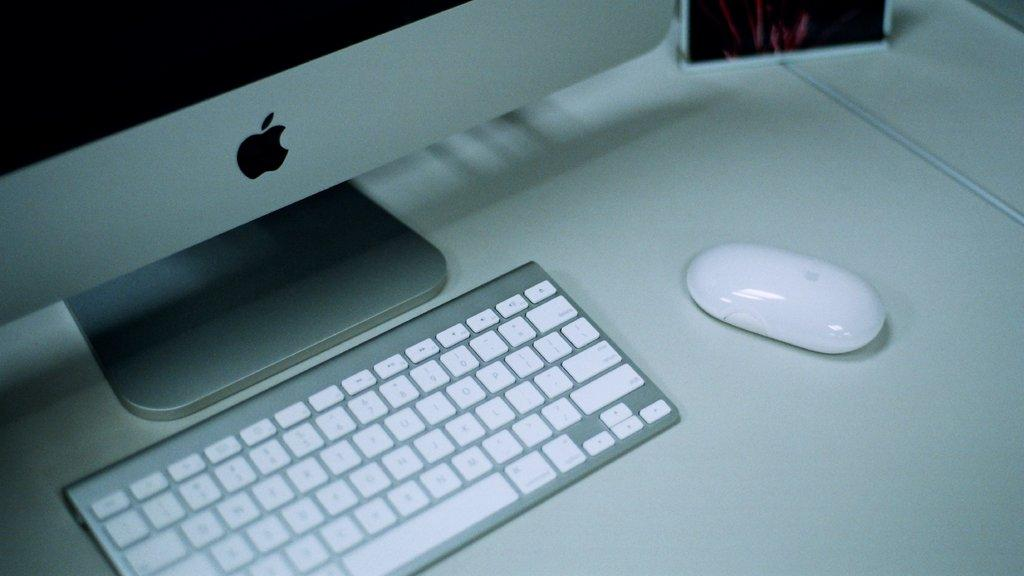What electronic device is visible in the image? There is a monitor in the image. What other input device is present in the image? There is a keyboard and a mouse in the image. Where are the monitor, keyboard, and mouse located? The monitor, keyboard, and mouse are placed on a table. What type of train can be seen passing by in the image? There is no train present in the image; it features a monitor, keyboard, and mouse on a table. 